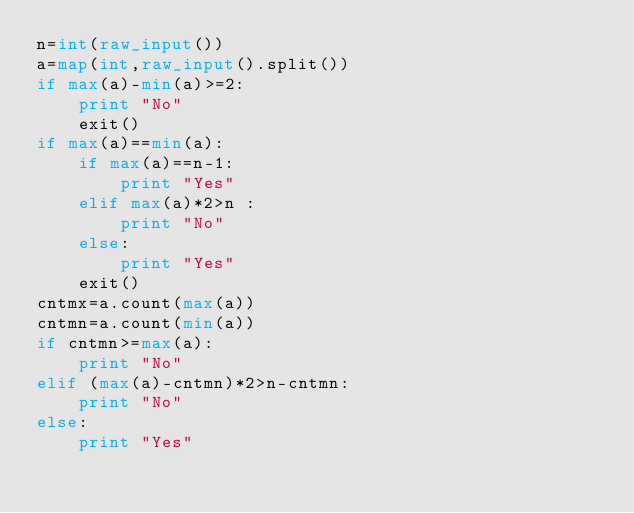Convert code to text. <code><loc_0><loc_0><loc_500><loc_500><_Python_>n=int(raw_input())
a=map(int,raw_input().split())
if max(a)-min(a)>=2:
    print "No"
    exit()
if max(a)==min(a):
    if max(a)==n-1:
        print "Yes"
    elif max(a)*2>n :
        print "No"
    else:
        print "Yes"
    exit()
cntmx=a.count(max(a))
cntmn=a.count(min(a))
if cntmn>=max(a):
    print "No"
elif (max(a)-cntmn)*2>n-cntmn:
    print "No"
else:
    print "Yes"
</code> 